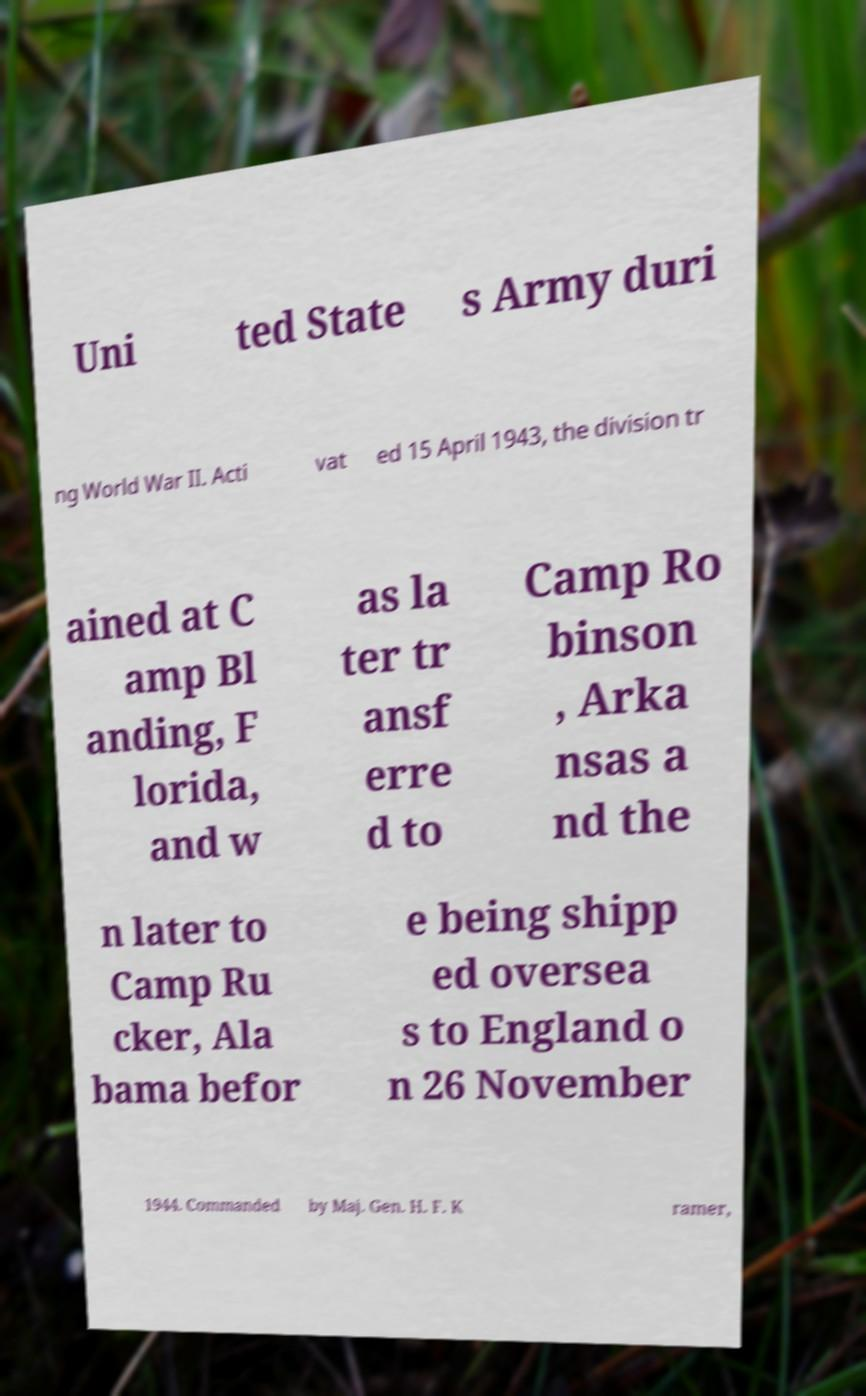Please identify and transcribe the text found in this image. Uni ted State s Army duri ng World War II. Acti vat ed 15 April 1943, the division tr ained at C amp Bl anding, F lorida, and w as la ter tr ansf erre d to Camp Ro binson , Arka nsas a nd the n later to Camp Ru cker, Ala bama befor e being shipp ed oversea s to England o n 26 November 1944. Commanded by Maj. Gen. H. F. K ramer, 